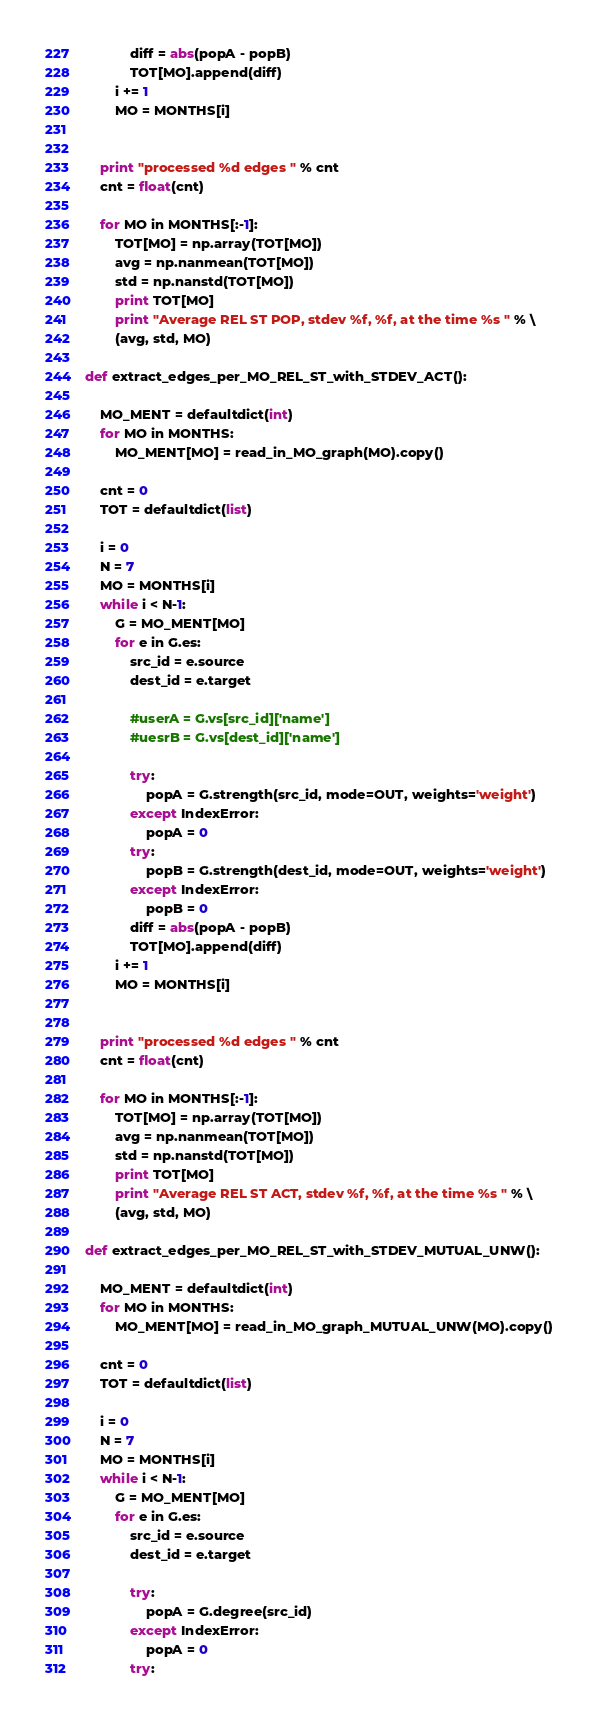Convert code to text. <code><loc_0><loc_0><loc_500><loc_500><_Python_>			diff = abs(popA - popB)
			TOT[MO].append(diff)
		i += 1
		MO = MONTHS[i]


	print "processed %d edges " % cnt
	cnt = float(cnt)

	for MO in MONTHS[:-1]:
		TOT[MO] = np.array(TOT[MO])
		avg = np.nanmean(TOT[MO])
		std = np.nanstd(TOT[MO])
		print TOT[MO]
		print "Average REL ST POP, stdev %f, %f, at the time %s " % \
		(avg, std, MO)

def extract_edges_per_MO_REL_ST_with_STDEV_ACT():

	MO_MENT = defaultdict(int)
	for MO in MONTHS:
		MO_MENT[MO] = read_in_MO_graph(MO).copy()

	cnt = 0
	TOT = defaultdict(list)

	i = 0
	N = 7
	MO = MONTHS[i]
	while i < N-1:
		G = MO_MENT[MO]
		for e in G.es:
			src_id = e.source
			dest_id = e.target

			#userA = G.vs[src_id]['name']
			#uesrB = G.vs[dest_id]['name']

			try:
				popA = G.strength(src_id, mode=OUT, weights='weight')
			except IndexError:
				popA = 0 
			try:
				popB = G.strength(dest_id, mode=OUT, weights='weight')
			except IndexError:
				popB = 0 
			diff = abs(popA - popB)
			TOT[MO].append(diff)
		i += 1
		MO = MONTHS[i]


	print "processed %d edges " % cnt
	cnt = float(cnt)

	for MO in MONTHS[:-1]:
		TOT[MO] = np.array(TOT[MO])
		avg = np.nanmean(TOT[MO])
		std = np.nanstd(TOT[MO])
		print TOT[MO]
		print "Average REL ST ACT, stdev %f, %f, at the time %s " % \
		(avg, std, MO)

def extract_edges_per_MO_REL_ST_with_STDEV_MUTUAL_UNW():

	MO_MENT = defaultdict(int)
	for MO in MONTHS:
		MO_MENT[MO] = read_in_MO_graph_MUTUAL_UNW(MO).copy()

	cnt = 0
	TOT = defaultdict(list)

	i = 0
	N = 7
	MO = MONTHS[i]
	while i < N-1:
		G = MO_MENT[MO]
		for e in G.es:
			src_id = e.source
			dest_id = e.target

			try:
				popA = G.degree(src_id)
			except IndexError:
				popA = 0 
			try:</code> 